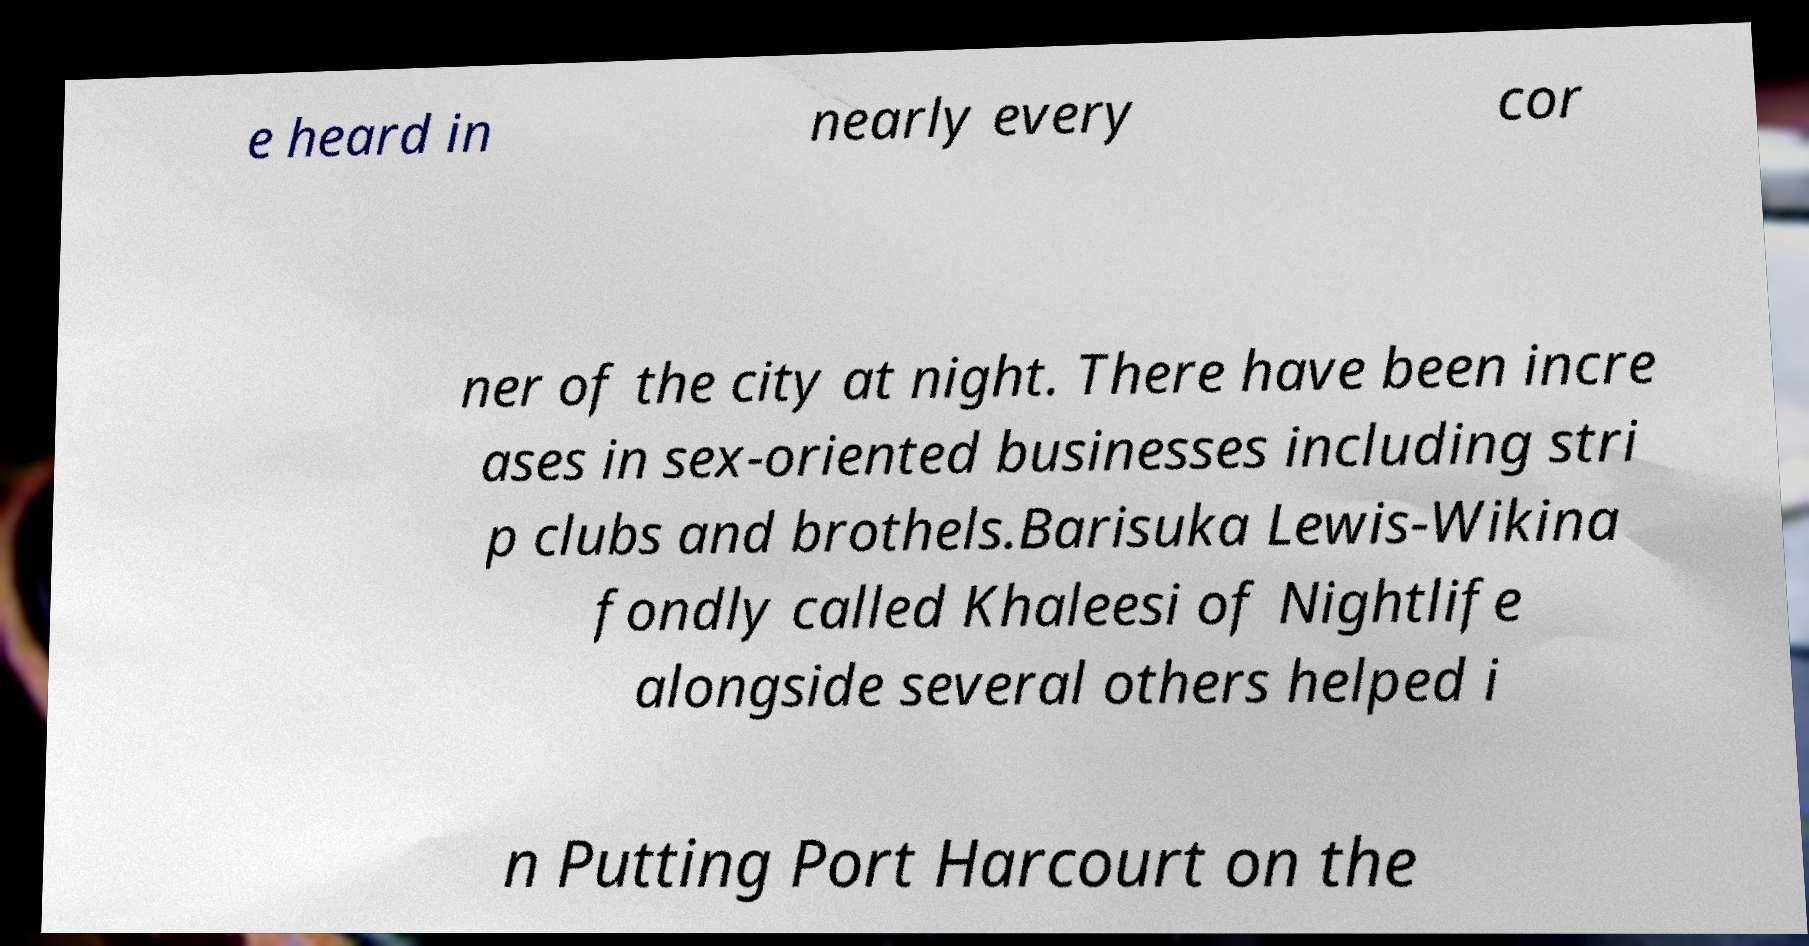Can you accurately transcribe the text from the provided image for me? e heard in nearly every cor ner of the city at night. There have been incre ases in sex-oriented businesses including stri p clubs and brothels.Barisuka Lewis-Wikina fondly called Khaleesi of Nightlife alongside several others helped i n Putting Port Harcourt on the 